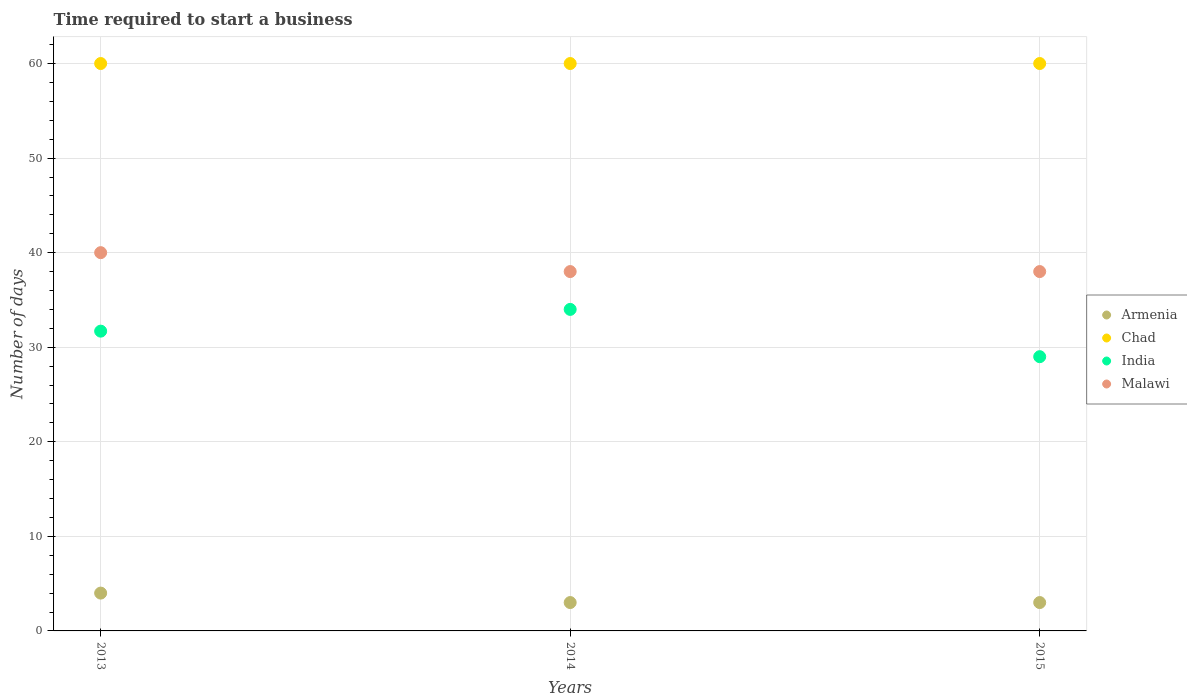What is the number of days required to start a business in Armenia in 2015?
Ensure brevity in your answer.  3. Across all years, what is the maximum number of days required to start a business in Chad?
Make the answer very short. 60. Across all years, what is the minimum number of days required to start a business in Armenia?
Your response must be concise. 3. In which year was the number of days required to start a business in Armenia maximum?
Provide a short and direct response. 2013. In which year was the number of days required to start a business in Chad minimum?
Keep it short and to the point. 2013. What is the total number of days required to start a business in India in the graph?
Your response must be concise. 94.7. What is the difference between the number of days required to start a business in Chad in 2013 and that in 2015?
Provide a short and direct response. 0. What is the difference between the number of days required to start a business in Chad in 2013 and the number of days required to start a business in Malawi in 2014?
Provide a short and direct response. 22. What is the average number of days required to start a business in India per year?
Provide a short and direct response. 31.57. In the year 2014, what is the difference between the number of days required to start a business in Chad and number of days required to start a business in Malawi?
Offer a terse response. 22. In how many years, is the number of days required to start a business in Chad greater than 28 days?
Provide a short and direct response. 3. What is the ratio of the number of days required to start a business in India in 2013 to that in 2014?
Offer a terse response. 0.93. Is the number of days required to start a business in India in 2014 less than that in 2015?
Offer a very short reply. No. What is the difference between the highest and the lowest number of days required to start a business in Armenia?
Ensure brevity in your answer.  1. In how many years, is the number of days required to start a business in Armenia greater than the average number of days required to start a business in Armenia taken over all years?
Provide a short and direct response. 1. Is the sum of the number of days required to start a business in India in 2013 and 2014 greater than the maximum number of days required to start a business in Malawi across all years?
Your answer should be very brief. Yes. Is it the case that in every year, the sum of the number of days required to start a business in Chad and number of days required to start a business in Armenia  is greater than the number of days required to start a business in Malawi?
Offer a terse response. Yes. Does the number of days required to start a business in India monotonically increase over the years?
Provide a short and direct response. No. How many dotlines are there?
Your answer should be compact. 4. How many years are there in the graph?
Your answer should be very brief. 3. Does the graph contain any zero values?
Make the answer very short. No. Does the graph contain grids?
Provide a succinct answer. Yes. How are the legend labels stacked?
Your answer should be compact. Vertical. What is the title of the graph?
Your response must be concise. Time required to start a business. Does "Korea (Democratic)" appear as one of the legend labels in the graph?
Your response must be concise. No. What is the label or title of the Y-axis?
Provide a succinct answer. Number of days. What is the Number of days in Armenia in 2013?
Provide a succinct answer. 4. What is the Number of days in India in 2013?
Make the answer very short. 31.7. What is the Number of days of Armenia in 2014?
Give a very brief answer. 3. What is the Number of days in India in 2014?
Give a very brief answer. 34. What is the Number of days of Malawi in 2014?
Make the answer very short. 38. What is the Number of days in Chad in 2015?
Offer a very short reply. 60. What is the Number of days in India in 2015?
Your answer should be compact. 29. What is the Number of days in Malawi in 2015?
Ensure brevity in your answer.  38. Across all years, what is the maximum Number of days in Chad?
Your response must be concise. 60. Across all years, what is the minimum Number of days of Chad?
Your answer should be very brief. 60. Across all years, what is the minimum Number of days of Malawi?
Keep it short and to the point. 38. What is the total Number of days in Armenia in the graph?
Your answer should be compact. 10. What is the total Number of days in Chad in the graph?
Your answer should be compact. 180. What is the total Number of days of India in the graph?
Make the answer very short. 94.7. What is the total Number of days of Malawi in the graph?
Give a very brief answer. 116. What is the difference between the Number of days in Chad in 2013 and that in 2014?
Provide a succinct answer. 0. What is the difference between the Number of days in India in 2013 and that in 2014?
Ensure brevity in your answer.  -2.3. What is the difference between the Number of days in Malawi in 2013 and that in 2014?
Offer a very short reply. 2. What is the difference between the Number of days of Armenia in 2013 and that in 2015?
Offer a very short reply. 1. What is the difference between the Number of days of Chad in 2013 and that in 2015?
Your answer should be compact. 0. What is the difference between the Number of days of Malawi in 2013 and that in 2015?
Offer a very short reply. 2. What is the difference between the Number of days in Chad in 2014 and that in 2015?
Your answer should be compact. 0. What is the difference between the Number of days of Malawi in 2014 and that in 2015?
Offer a terse response. 0. What is the difference between the Number of days in Armenia in 2013 and the Number of days in Chad in 2014?
Offer a very short reply. -56. What is the difference between the Number of days in Armenia in 2013 and the Number of days in India in 2014?
Your answer should be compact. -30. What is the difference between the Number of days of Armenia in 2013 and the Number of days of Malawi in 2014?
Keep it short and to the point. -34. What is the difference between the Number of days of Chad in 2013 and the Number of days of Malawi in 2014?
Offer a very short reply. 22. What is the difference between the Number of days of Armenia in 2013 and the Number of days of Chad in 2015?
Ensure brevity in your answer.  -56. What is the difference between the Number of days of Armenia in 2013 and the Number of days of Malawi in 2015?
Offer a very short reply. -34. What is the difference between the Number of days in Armenia in 2014 and the Number of days in Chad in 2015?
Your answer should be very brief. -57. What is the difference between the Number of days of Armenia in 2014 and the Number of days of Malawi in 2015?
Give a very brief answer. -35. What is the difference between the Number of days of Chad in 2014 and the Number of days of India in 2015?
Your answer should be compact. 31. What is the difference between the Number of days of Chad in 2014 and the Number of days of Malawi in 2015?
Make the answer very short. 22. What is the difference between the Number of days in India in 2014 and the Number of days in Malawi in 2015?
Give a very brief answer. -4. What is the average Number of days in Armenia per year?
Make the answer very short. 3.33. What is the average Number of days in Chad per year?
Provide a succinct answer. 60. What is the average Number of days of India per year?
Offer a very short reply. 31.57. What is the average Number of days in Malawi per year?
Make the answer very short. 38.67. In the year 2013, what is the difference between the Number of days in Armenia and Number of days in Chad?
Offer a terse response. -56. In the year 2013, what is the difference between the Number of days of Armenia and Number of days of India?
Ensure brevity in your answer.  -27.7. In the year 2013, what is the difference between the Number of days of Armenia and Number of days of Malawi?
Offer a terse response. -36. In the year 2013, what is the difference between the Number of days in Chad and Number of days in India?
Offer a terse response. 28.3. In the year 2013, what is the difference between the Number of days of India and Number of days of Malawi?
Ensure brevity in your answer.  -8.3. In the year 2014, what is the difference between the Number of days of Armenia and Number of days of Chad?
Keep it short and to the point. -57. In the year 2014, what is the difference between the Number of days of Armenia and Number of days of India?
Offer a terse response. -31. In the year 2014, what is the difference between the Number of days of Armenia and Number of days of Malawi?
Provide a short and direct response. -35. In the year 2014, what is the difference between the Number of days of Chad and Number of days of India?
Make the answer very short. 26. In the year 2015, what is the difference between the Number of days of Armenia and Number of days of Chad?
Provide a short and direct response. -57. In the year 2015, what is the difference between the Number of days of Armenia and Number of days of India?
Provide a short and direct response. -26. In the year 2015, what is the difference between the Number of days in Armenia and Number of days in Malawi?
Your answer should be very brief. -35. In the year 2015, what is the difference between the Number of days of Chad and Number of days of India?
Offer a terse response. 31. In the year 2015, what is the difference between the Number of days in Chad and Number of days in Malawi?
Offer a very short reply. 22. In the year 2015, what is the difference between the Number of days of India and Number of days of Malawi?
Make the answer very short. -9. What is the ratio of the Number of days of Armenia in 2013 to that in 2014?
Offer a very short reply. 1.33. What is the ratio of the Number of days of India in 2013 to that in 2014?
Give a very brief answer. 0.93. What is the ratio of the Number of days of Malawi in 2013 to that in 2014?
Ensure brevity in your answer.  1.05. What is the ratio of the Number of days of Chad in 2013 to that in 2015?
Your response must be concise. 1. What is the ratio of the Number of days of India in 2013 to that in 2015?
Keep it short and to the point. 1.09. What is the ratio of the Number of days in Malawi in 2013 to that in 2015?
Provide a succinct answer. 1.05. What is the ratio of the Number of days in Armenia in 2014 to that in 2015?
Your answer should be very brief. 1. What is the ratio of the Number of days of Chad in 2014 to that in 2015?
Ensure brevity in your answer.  1. What is the ratio of the Number of days in India in 2014 to that in 2015?
Make the answer very short. 1.17. What is the difference between the highest and the second highest Number of days of Armenia?
Provide a succinct answer. 1. What is the difference between the highest and the second highest Number of days of Chad?
Provide a short and direct response. 0. What is the difference between the highest and the second highest Number of days of India?
Your answer should be compact. 2.3. What is the difference between the highest and the lowest Number of days of Armenia?
Give a very brief answer. 1. What is the difference between the highest and the lowest Number of days of Chad?
Your answer should be compact. 0. 